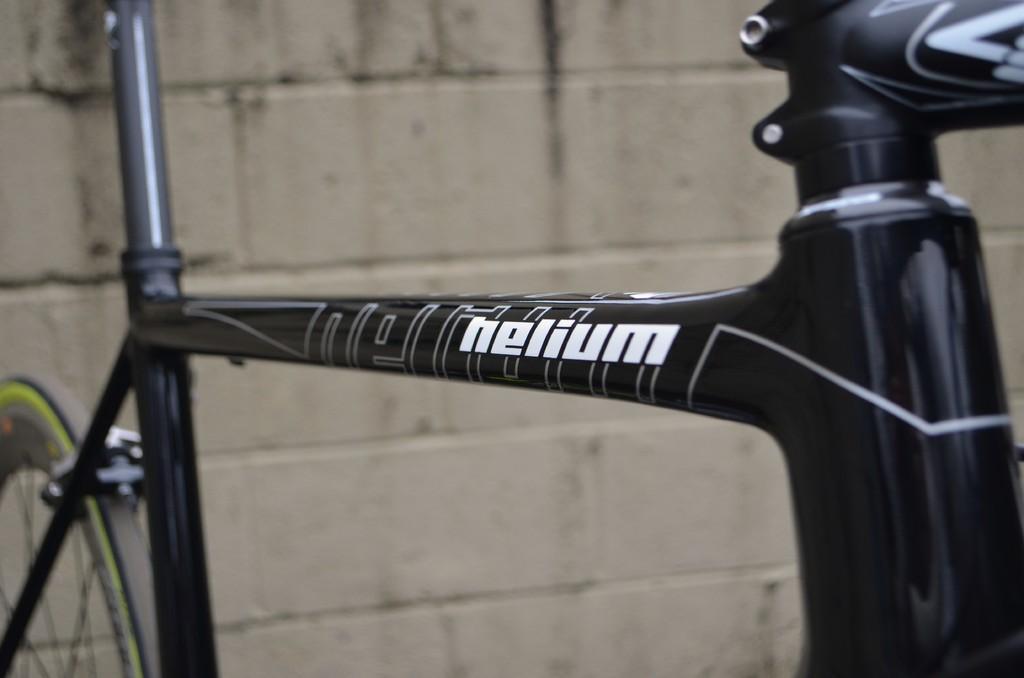In one or two sentences, can you explain what this image depicts? In this picture we can see a bicycle and we can see a wall in the background. 